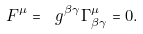Convert formula to latex. <formula><loc_0><loc_0><loc_500><loc_500>F ^ { \mu } = \ g ^ { \beta \gamma } \Gamma _ { \beta \gamma } ^ { \mu } = 0 .</formula> 